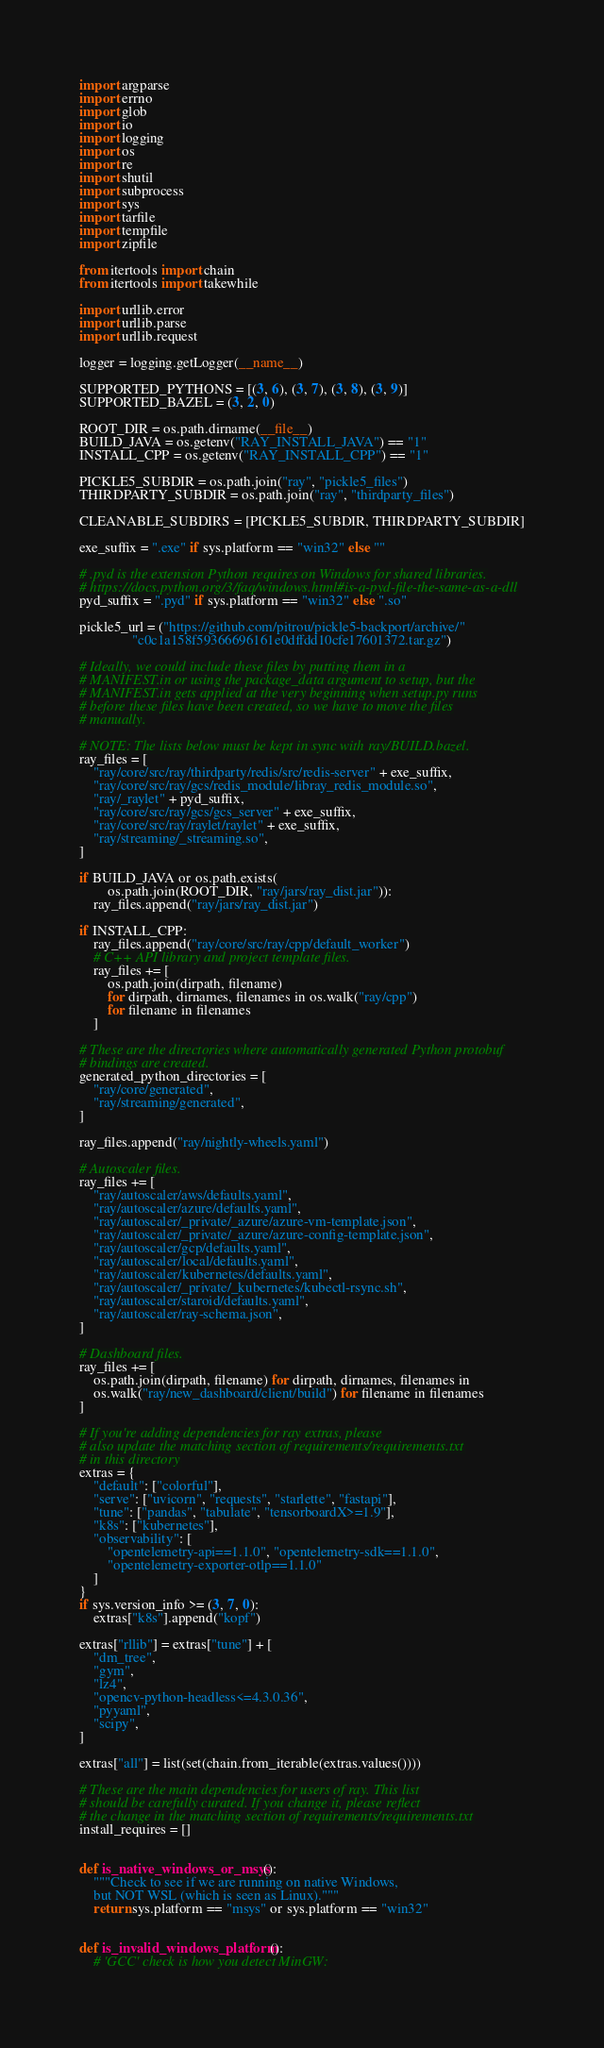<code> <loc_0><loc_0><loc_500><loc_500><_Python_>import argparse
import errno
import glob
import io
import logging
import os
import re
import shutil
import subprocess
import sys
import tarfile
import tempfile
import zipfile

from itertools import chain
from itertools import takewhile

import urllib.error
import urllib.parse
import urllib.request

logger = logging.getLogger(__name__)

SUPPORTED_PYTHONS = [(3, 6), (3, 7), (3, 8), (3, 9)]
SUPPORTED_BAZEL = (3, 2, 0)

ROOT_DIR = os.path.dirname(__file__)
BUILD_JAVA = os.getenv("RAY_INSTALL_JAVA") == "1"
INSTALL_CPP = os.getenv("RAY_INSTALL_CPP") == "1"

PICKLE5_SUBDIR = os.path.join("ray", "pickle5_files")
THIRDPARTY_SUBDIR = os.path.join("ray", "thirdparty_files")

CLEANABLE_SUBDIRS = [PICKLE5_SUBDIR, THIRDPARTY_SUBDIR]

exe_suffix = ".exe" if sys.platform == "win32" else ""

# .pyd is the extension Python requires on Windows for shared libraries.
# https://docs.python.org/3/faq/windows.html#is-a-pyd-file-the-same-as-a-dll
pyd_suffix = ".pyd" if sys.platform == "win32" else ".so"

pickle5_url = ("https://github.com/pitrou/pickle5-backport/archive/"
               "c0c1a158f59366696161e0dffdd10cfe17601372.tar.gz")

# Ideally, we could include these files by putting them in a
# MANIFEST.in or using the package_data argument to setup, but the
# MANIFEST.in gets applied at the very beginning when setup.py runs
# before these files have been created, so we have to move the files
# manually.

# NOTE: The lists below must be kept in sync with ray/BUILD.bazel.
ray_files = [
    "ray/core/src/ray/thirdparty/redis/src/redis-server" + exe_suffix,
    "ray/core/src/ray/gcs/redis_module/libray_redis_module.so",
    "ray/_raylet" + pyd_suffix,
    "ray/core/src/ray/gcs/gcs_server" + exe_suffix,
    "ray/core/src/ray/raylet/raylet" + exe_suffix,
    "ray/streaming/_streaming.so",
]

if BUILD_JAVA or os.path.exists(
        os.path.join(ROOT_DIR, "ray/jars/ray_dist.jar")):
    ray_files.append("ray/jars/ray_dist.jar")

if INSTALL_CPP:
    ray_files.append("ray/core/src/ray/cpp/default_worker")
    # C++ API library and project template files.
    ray_files += [
        os.path.join(dirpath, filename)
        for dirpath, dirnames, filenames in os.walk("ray/cpp")
        for filename in filenames
    ]

# These are the directories where automatically generated Python protobuf
# bindings are created.
generated_python_directories = [
    "ray/core/generated",
    "ray/streaming/generated",
]

ray_files.append("ray/nightly-wheels.yaml")

# Autoscaler files.
ray_files += [
    "ray/autoscaler/aws/defaults.yaml",
    "ray/autoscaler/azure/defaults.yaml",
    "ray/autoscaler/_private/_azure/azure-vm-template.json",
    "ray/autoscaler/_private/_azure/azure-config-template.json",
    "ray/autoscaler/gcp/defaults.yaml",
    "ray/autoscaler/local/defaults.yaml",
    "ray/autoscaler/kubernetes/defaults.yaml",
    "ray/autoscaler/_private/_kubernetes/kubectl-rsync.sh",
    "ray/autoscaler/staroid/defaults.yaml",
    "ray/autoscaler/ray-schema.json",
]

# Dashboard files.
ray_files += [
    os.path.join(dirpath, filename) for dirpath, dirnames, filenames in
    os.walk("ray/new_dashboard/client/build") for filename in filenames
]

# If you're adding dependencies for ray extras, please
# also update the matching section of requirements/requirements.txt
# in this directory
extras = {
    "default": ["colorful"],
    "serve": ["uvicorn", "requests", "starlette", "fastapi"],
    "tune": ["pandas", "tabulate", "tensorboardX>=1.9"],
    "k8s": ["kubernetes"],
    "observability": [
        "opentelemetry-api==1.1.0", "opentelemetry-sdk==1.1.0",
        "opentelemetry-exporter-otlp==1.1.0"
    ]
}
if sys.version_info >= (3, 7, 0):
    extras["k8s"].append("kopf")

extras["rllib"] = extras["tune"] + [
    "dm_tree",
    "gym",
    "lz4",
    "opencv-python-headless<=4.3.0.36",
    "pyyaml",
    "scipy",
]

extras["all"] = list(set(chain.from_iterable(extras.values())))

# These are the main dependencies for users of ray. This list
# should be carefully curated. If you change it, please reflect
# the change in the matching section of requirements/requirements.txt
install_requires = []


def is_native_windows_or_msys():
    """Check to see if we are running on native Windows,
    but NOT WSL (which is seen as Linux)."""
    return sys.platform == "msys" or sys.platform == "win32"


def is_invalid_windows_platform():
    # 'GCC' check is how you detect MinGW:</code> 